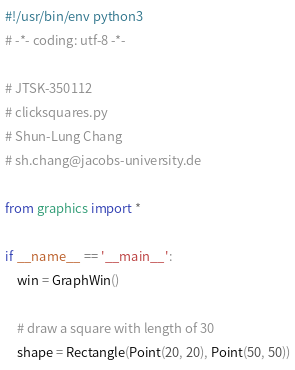<code> <loc_0><loc_0><loc_500><loc_500><_Python_>#!/usr/bin/env python3
# -*- coding: utf-8 -*-

# JTSK-350112
# clicksquares.py
# Shun-Lung Chang
# sh.chang@jacobs-university.de

from graphics import *

if __name__ == '__main__':
    win = GraphWin()
    
    # draw a square with length of 30
    shape = Rectangle(Point(20, 20), Point(50, 50))</code> 